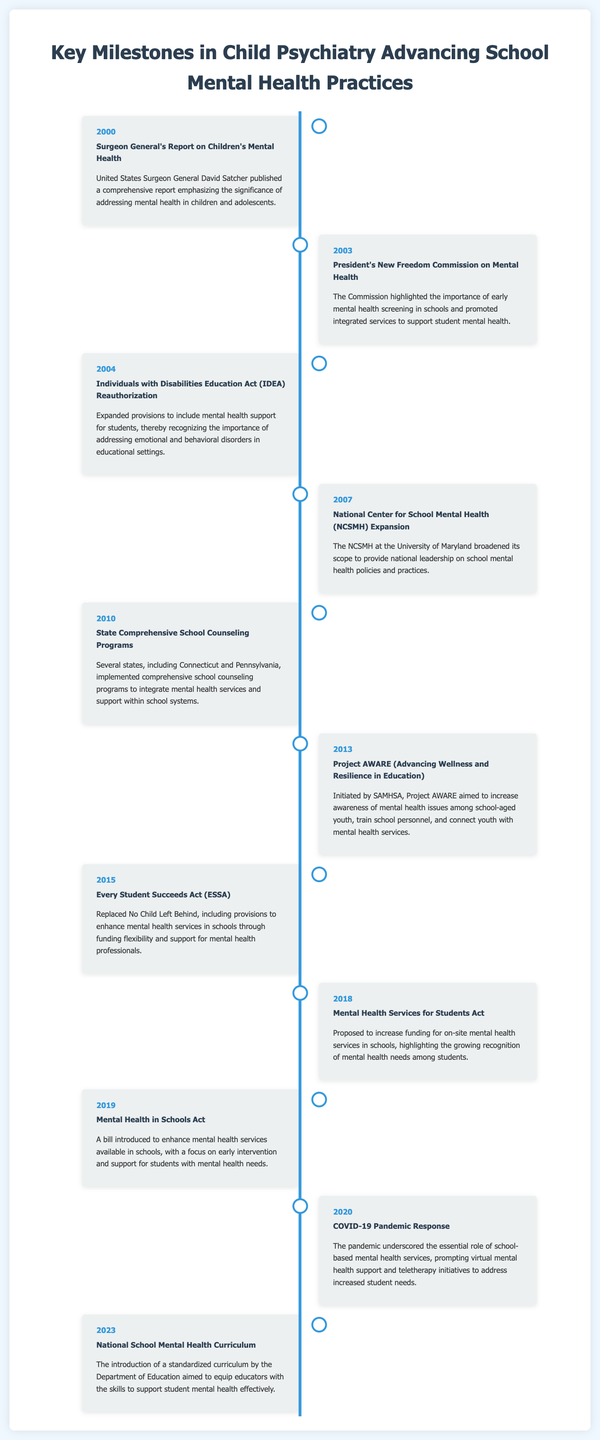What year was the Surgeon General's Report on Children's Mental Health published? The document states that the Surgeon General's Report was published in 2000.
Answer: 2000 What commission highlighted the importance of early mental health screening in schools? According to the timeline, the President's New Freedom Commission on Mental Health emphasized early screening in schools.
Answer: President's New Freedom Commission on Mental Health What significant act was reauthorized in 2004 to support mental health in schools? The Individuals with Disabilities Education Act (IDEA) was reauthorized in 2004 to include mental health support.
Answer: Individuals with Disabilities Education Act (IDEA) What initiative was launched in 2013 to connect youth with mental health services? Project AWARE (Advancing Wellness and Resilience in Education) was initiated in 2013.
Answer: Project AWARE What major legislation replaced No Child Left Behind in 2015? The Every Student Succeeds Act (ESSA) replaced No Child Left Behind in 2015 and included provisions for mental health services.
Answer: Every Student Succeeds Act (ESSA) How did the COVID-19 pandemic affect school mental health services in 2020? The document notes that the pandemic underscored the essential role of school-based mental health services, leading to virtual support initiatives.
Answer: Virtual mental health support What curriculum was introduced in 2023 to aid educators? The National School Mental Health Curriculum was introduced by the Department of Education in 2023.
Answer: National School Mental Health Curriculum In what year did the National Center for School Mental Health (NCSMH) expand its scope? The NCSMH expanded its scope in 2007, according to the timeline.
Answer: 2007 How many events from the timeline are specifically focused on legislation? The timeline lists four events that mention legislation related to school mental health.
Answer: Four 